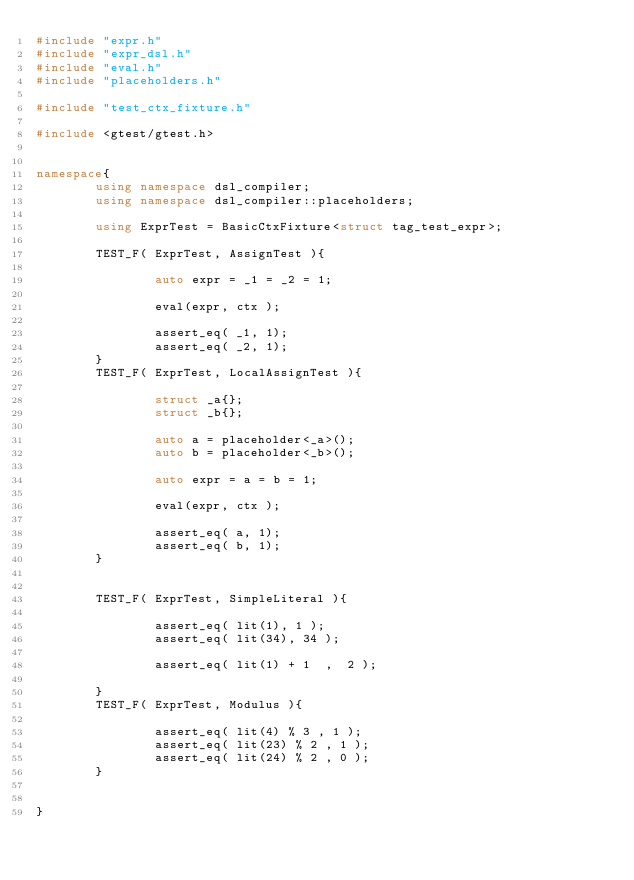<code> <loc_0><loc_0><loc_500><loc_500><_C++_>#include "expr.h"
#include "expr_dsl.h"
#include "eval.h"
#include "placeholders.h"

#include "test_ctx_fixture.h"

#include <gtest/gtest.h>


namespace{
        using namespace dsl_compiler;
        using namespace dsl_compiler::placeholders;

        using ExprTest = BasicCtxFixture<struct tag_test_expr>;

        TEST_F( ExprTest, AssignTest ){

                auto expr = _1 = _2 = 1;

                eval(expr, ctx );

                assert_eq( _1, 1);
                assert_eq( _2, 1);
        }
        TEST_F( ExprTest, LocalAssignTest ){

                struct _a{};
                struct _b{};

                auto a = placeholder<_a>();
                auto b = placeholder<_b>();

                auto expr = a = b = 1;

                eval(expr, ctx );

                assert_eq( a, 1);
                assert_eq( b, 1);
        }
        
        
        TEST_F( ExprTest, SimpleLiteral ){

                assert_eq( lit(1), 1 );
                assert_eq( lit(34), 34 );
                
                assert_eq( lit(1) + 1  ,  2 );

        }
        TEST_F( ExprTest, Modulus ){

                assert_eq( lit(4) % 3 , 1 );
                assert_eq( lit(23) % 2 , 1 );
                assert_eq( lit(24) % 2 , 0 );
        }


}

</code> 